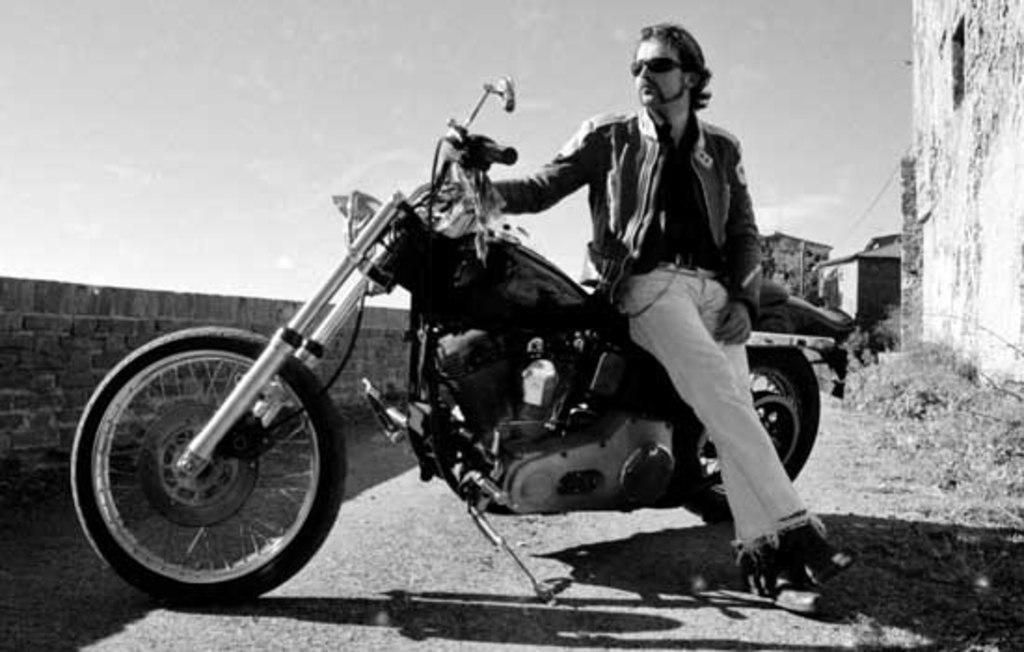Who is the main subject in the image? There is a man in the image. What is the man doing in the image? The man is sitting on a motorbike. What accessory is the man wearing in the image? The man is wearing spectacles. What can be seen in the background of the image? There is a wall and the sky visible in the background of the image. Can you see any events happening on the island in the image? There is no island present in the image; it features a man sitting on a motorbike with a wall and the sky visible in the background. What type of pear is the man holding in the image? There is no pear present in the image. 